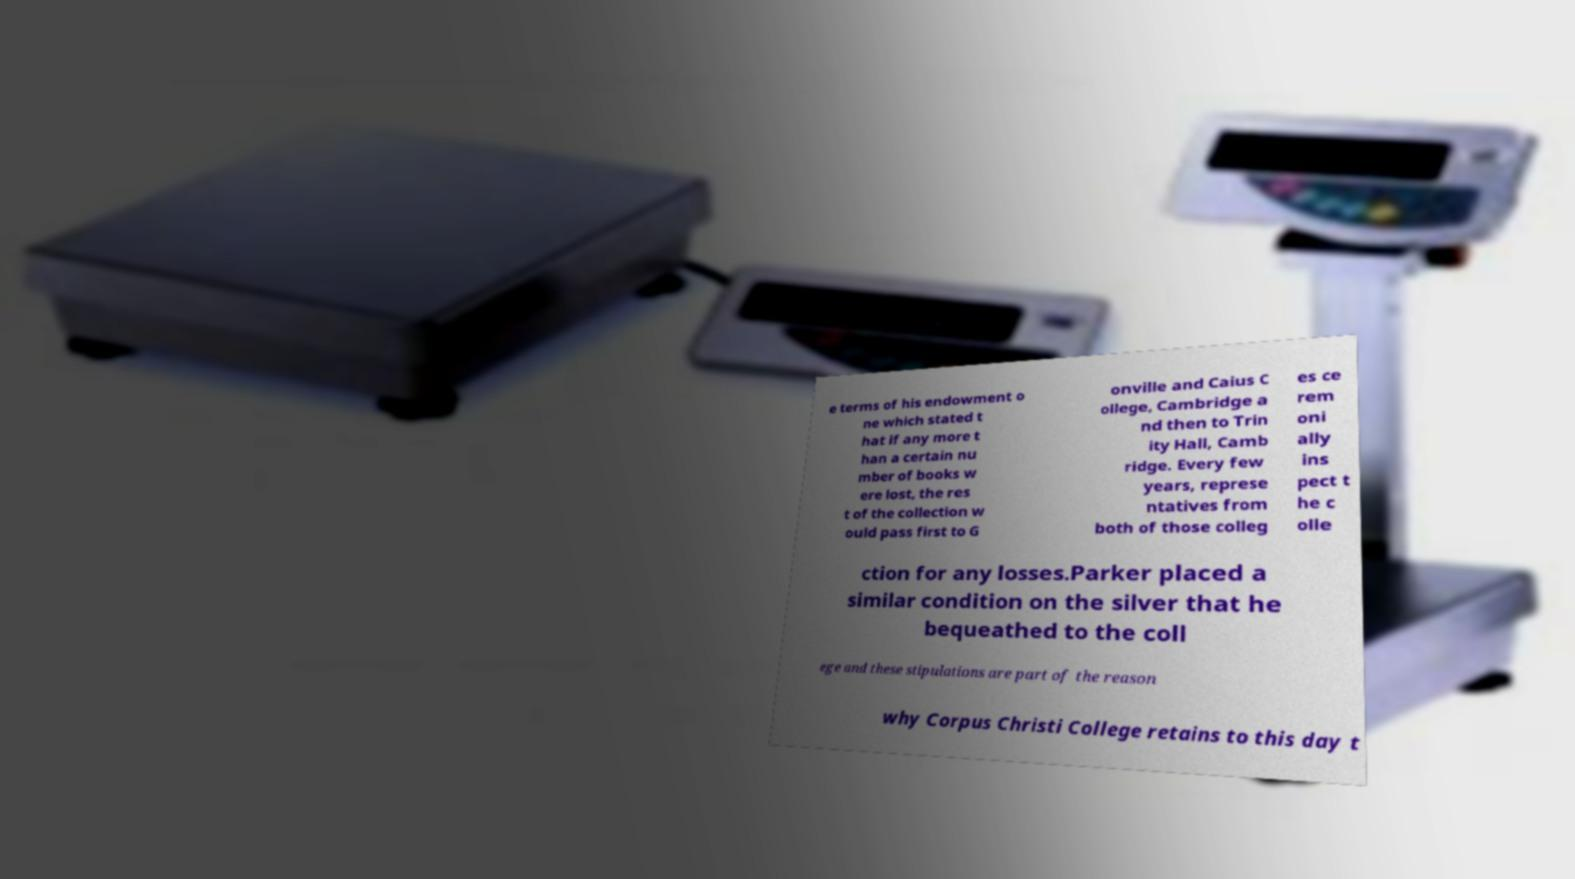There's text embedded in this image that I need extracted. Can you transcribe it verbatim? e terms of his endowment o ne which stated t hat if any more t han a certain nu mber of books w ere lost, the res t of the collection w ould pass first to G onville and Caius C ollege, Cambridge a nd then to Trin ity Hall, Camb ridge. Every few years, represe ntatives from both of those colleg es ce rem oni ally ins pect t he c olle ction for any losses.Parker placed a similar condition on the silver that he bequeathed to the coll ege and these stipulations are part of the reason why Corpus Christi College retains to this day t 